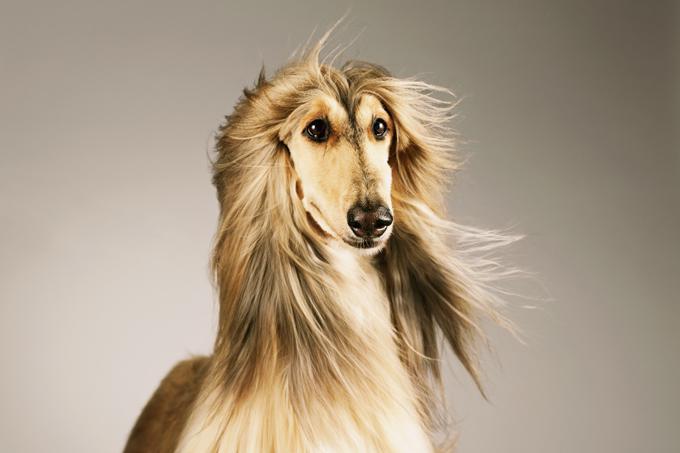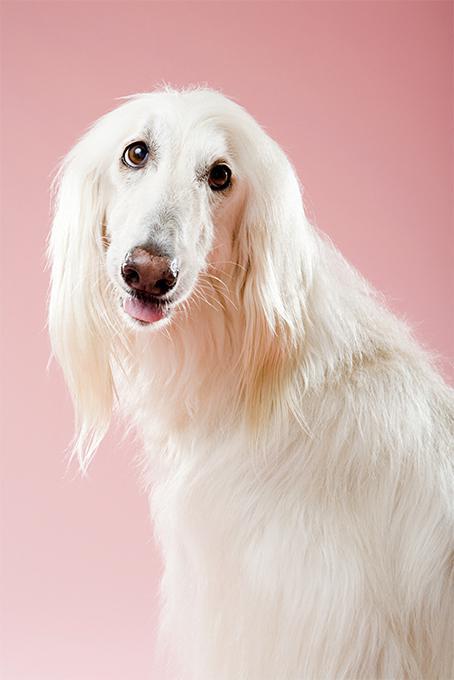The first image is the image on the left, the second image is the image on the right. Considering the images on both sides, is "The dog in the image on the left is outside." valid? Answer yes or no. No. 